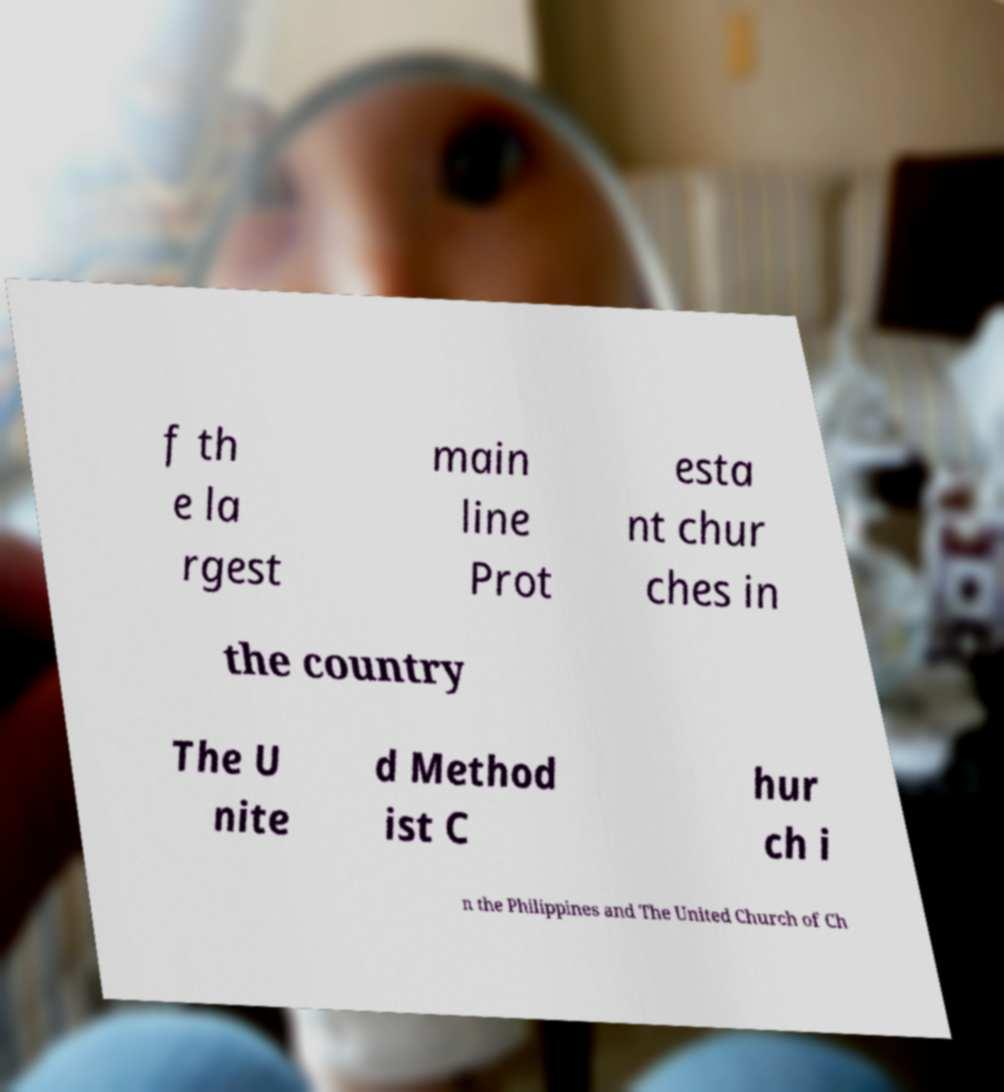Can you accurately transcribe the text from the provided image for me? f th e la rgest main line Prot esta nt chur ches in the country The U nite d Method ist C hur ch i n the Philippines and The United Church of Ch 